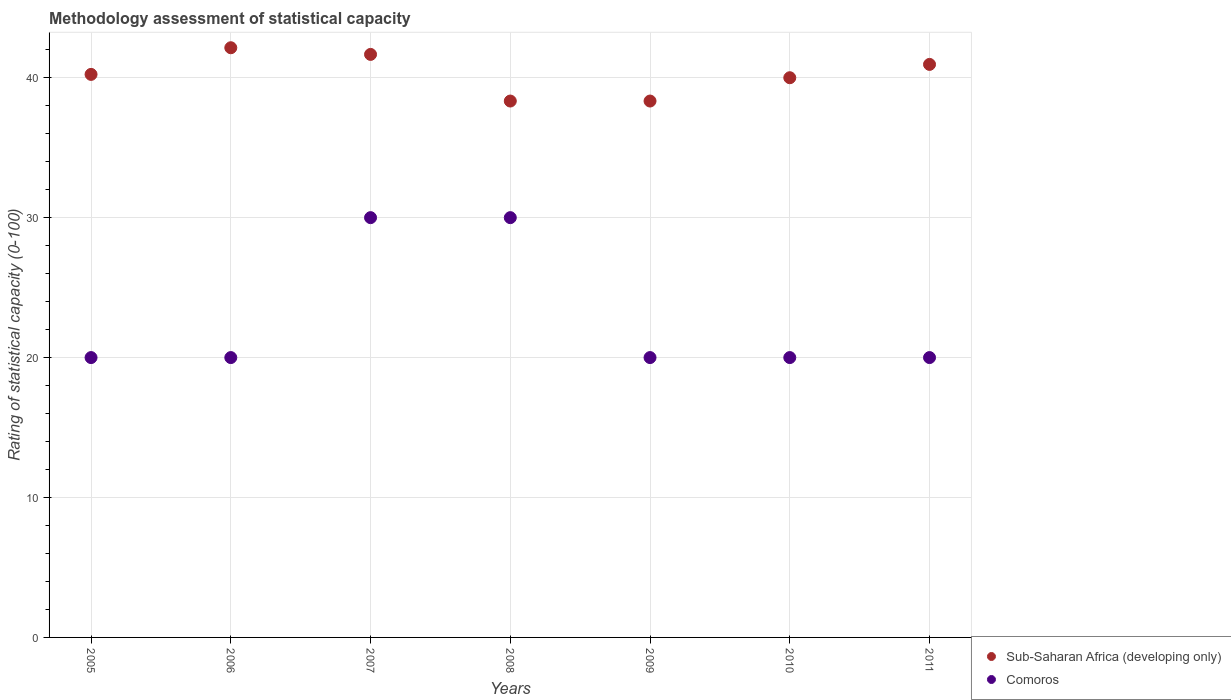How many different coloured dotlines are there?
Keep it short and to the point. 2. Is the number of dotlines equal to the number of legend labels?
Provide a short and direct response. Yes. Across all years, what is the maximum rating of statistical capacity in Sub-Saharan Africa (developing only)?
Provide a succinct answer. 42.14. In which year was the rating of statistical capacity in Comoros minimum?
Provide a succinct answer. 2005. What is the total rating of statistical capacity in Comoros in the graph?
Provide a short and direct response. 160. What is the difference between the rating of statistical capacity in Sub-Saharan Africa (developing only) in 2006 and that in 2008?
Make the answer very short. 3.81. What is the difference between the rating of statistical capacity in Sub-Saharan Africa (developing only) in 2010 and the rating of statistical capacity in Comoros in 2007?
Provide a succinct answer. 10. What is the average rating of statistical capacity in Comoros per year?
Provide a short and direct response. 22.86. In the year 2009, what is the difference between the rating of statistical capacity in Sub-Saharan Africa (developing only) and rating of statistical capacity in Comoros?
Your response must be concise. 18.33. What is the difference between the highest and the second highest rating of statistical capacity in Sub-Saharan Africa (developing only)?
Offer a very short reply. 0.48. What is the difference between the highest and the lowest rating of statistical capacity in Sub-Saharan Africa (developing only)?
Keep it short and to the point. 3.81. In how many years, is the rating of statistical capacity in Sub-Saharan Africa (developing only) greater than the average rating of statistical capacity in Sub-Saharan Africa (developing only) taken over all years?
Offer a terse response. 3. Is the sum of the rating of statistical capacity in Comoros in 2006 and 2008 greater than the maximum rating of statistical capacity in Sub-Saharan Africa (developing only) across all years?
Make the answer very short. Yes. Is the rating of statistical capacity in Sub-Saharan Africa (developing only) strictly greater than the rating of statistical capacity in Comoros over the years?
Your answer should be compact. Yes. How many years are there in the graph?
Offer a terse response. 7. What is the title of the graph?
Your answer should be compact. Methodology assessment of statistical capacity. What is the label or title of the Y-axis?
Offer a very short reply. Rating of statistical capacity (0-100). What is the Rating of statistical capacity (0-100) of Sub-Saharan Africa (developing only) in 2005?
Keep it short and to the point. 40.24. What is the Rating of statistical capacity (0-100) in Comoros in 2005?
Your answer should be very brief. 20. What is the Rating of statistical capacity (0-100) in Sub-Saharan Africa (developing only) in 2006?
Keep it short and to the point. 42.14. What is the Rating of statistical capacity (0-100) of Sub-Saharan Africa (developing only) in 2007?
Provide a succinct answer. 41.67. What is the Rating of statistical capacity (0-100) of Sub-Saharan Africa (developing only) in 2008?
Your response must be concise. 38.33. What is the Rating of statistical capacity (0-100) in Sub-Saharan Africa (developing only) in 2009?
Ensure brevity in your answer.  38.33. What is the Rating of statistical capacity (0-100) in Comoros in 2009?
Offer a terse response. 20. What is the Rating of statistical capacity (0-100) in Sub-Saharan Africa (developing only) in 2010?
Your response must be concise. 40. What is the Rating of statistical capacity (0-100) of Sub-Saharan Africa (developing only) in 2011?
Your answer should be compact. 40.95. What is the Rating of statistical capacity (0-100) in Comoros in 2011?
Your answer should be compact. 20. Across all years, what is the maximum Rating of statistical capacity (0-100) of Sub-Saharan Africa (developing only)?
Offer a very short reply. 42.14. Across all years, what is the maximum Rating of statistical capacity (0-100) in Comoros?
Your answer should be very brief. 30. Across all years, what is the minimum Rating of statistical capacity (0-100) in Sub-Saharan Africa (developing only)?
Ensure brevity in your answer.  38.33. What is the total Rating of statistical capacity (0-100) in Sub-Saharan Africa (developing only) in the graph?
Make the answer very short. 281.67. What is the total Rating of statistical capacity (0-100) of Comoros in the graph?
Offer a terse response. 160. What is the difference between the Rating of statistical capacity (0-100) of Sub-Saharan Africa (developing only) in 2005 and that in 2006?
Your answer should be compact. -1.9. What is the difference between the Rating of statistical capacity (0-100) in Sub-Saharan Africa (developing only) in 2005 and that in 2007?
Your response must be concise. -1.43. What is the difference between the Rating of statistical capacity (0-100) in Comoros in 2005 and that in 2007?
Make the answer very short. -10. What is the difference between the Rating of statistical capacity (0-100) of Sub-Saharan Africa (developing only) in 2005 and that in 2008?
Your answer should be compact. 1.9. What is the difference between the Rating of statistical capacity (0-100) in Comoros in 2005 and that in 2008?
Provide a succinct answer. -10. What is the difference between the Rating of statistical capacity (0-100) of Sub-Saharan Africa (developing only) in 2005 and that in 2009?
Ensure brevity in your answer.  1.9. What is the difference between the Rating of statistical capacity (0-100) of Sub-Saharan Africa (developing only) in 2005 and that in 2010?
Your answer should be very brief. 0.24. What is the difference between the Rating of statistical capacity (0-100) of Comoros in 2005 and that in 2010?
Your answer should be compact. 0. What is the difference between the Rating of statistical capacity (0-100) in Sub-Saharan Africa (developing only) in 2005 and that in 2011?
Offer a terse response. -0.71. What is the difference between the Rating of statistical capacity (0-100) of Sub-Saharan Africa (developing only) in 2006 and that in 2007?
Ensure brevity in your answer.  0.48. What is the difference between the Rating of statistical capacity (0-100) in Sub-Saharan Africa (developing only) in 2006 and that in 2008?
Offer a terse response. 3.81. What is the difference between the Rating of statistical capacity (0-100) of Sub-Saharan Africa (developing only) in 2006 and that in 2009?
Provide a short and direct response. 3.81. What is the difference between the Rating of statistical capacity (0-100) of Sub-Saharan Africa (developing only) in 2006 and that in 2010?
Ensure brevity in your answer.  2.14. What is the difference between the Rating of statistical capacity (0-100) in Comoros in 2006 and that in 2010?
Your answer should be compact. 0. What is the difference between the Rating of statistical capacity (0-100) in Sub-Saharan Africa (developing only) in 2006 and that in 2011?
Your response must be concise. 1.19. What is the difference between the Rating of statistical capacity (0-100) in Sub-Saharan Africa (developing only) in 2007 and that in 2008?
Offer a very short reply. 3.33. What is the difference between the Rating of statistical capacity (0-100) in Comoros in 2007 and that in 2008?
Keep it short and to the point. 0. What is the difference between the Rating of statistical capacity (0-100) in Comoros in 2007 and that in 2009?
Ensure brevity in your answer.  10. What is the difference between the Rating of statistical capacity (0-100) of Sub-Saharan Africa (developing only) in 2007 and that in 2010?
Provide a succinct answer. 1.67. What is the difference between the Rating of statistical capacity (0-100) in Comoros in 2007 and that in 2010?
Ensure brevity in your answer.  10. What is the difference between the Rating of statistical capacity (0-100) of Sub-Saharan Africa (developing only) in 2007 and that in 2011?
Your answer should be compact. 0.71. What is the difference between the Rating of statistical capacity (0-100) in Sub-Saharan Africa (developing only) in 2008 and that in 2009?
Provide a succinct answer. 0. What is the difference between the Rating of statistical capacity (0-100) in Sub-Saharan Africa (developing only) in 2008 and that in 2010?
Offer a very short reply. -1.67. What is the difference between the Rating of statistical capacity (0-100) in Comoros in 2008 and that in 2010?
Provide a short and direct response. 10. What is the difference between the Rating of statistical capacity (0-100) in Sub-Saharan Africa (developing only) in 2008 and that in 2011?
Provide a succinct answer. -2.62. What is the difference between the Rating of statistical capacity (0-100) of Sub-Saharan Africa (developing only) in 2009 and that in 2010?
Make the answer very short. -1.67. What is the difference between the Rating of statistical capacity (0-100) of Comoros in 2009 and that in 2010?
Provide a succinct answer. 0. What is the difference between the Rating of statistical capacity (0-100) of Sub-Saharan Africa (developing only) in 2009 and that in 2011?
Keep it short and to the point. -2.62. What is the difference between the Rating of statistical capacity (0-100) in Sub-Saharan Africa (developing only) in 2010 and that in 2011?
Ensure brevity in your answer.  -0.95. What is the difference between the Rating of statistical capacity (0-100) in Sub-Saharan Africa (developing only) in 2005 and the Rating of statistical capacity (0-100) in Comoros in 2006?
Ensure brevity in your answer.  20.24. What is the difference between the Rating of statistical capacity (0-100) in Sub-Saharan Africa (developing only) in 2005 and the Rating of statistical capacity (0-100) in Comoros in 2007?
Your response must be concise. 10.24. What is the difference between the Rating of statistical capacity (0-100) of Sub-Saharan Africa (developing only) in 2005 and the Rating of statistical capacity (0-100) of Comoros in 2008?
Offer a very short reply. 10.24. What is the difference between the Rating of statistical capacity (0-100) of Sub-Saharan Africa (developing only) in 2005 and the Rating of statistical capacity (0-100) of Comoros in 2009?
Ensure brevity in your answer.  20.24. What is the difference between the Rating of statistical capacity (0-100) in Sub-Saharan Africa (developing only) in 2005 and the Rating of statistical capacity (0-100) in Comoros in 2010?
Ensure brevity in your answer.  20.24. What is the difference between the Rating of statistical capacity (0-100) in Sub-Saharan Africa (developing only) in 2005 and the Rating of statistical capacity (0-100) in Comoros in 2011?
Give a very brief answer. 20.24. What is the difference between the Rating of statistical capacity (0-100) of Sub-Saharan Africa (developing only) in 2006 and the Rating of statistical capacity (0-100) of Comoros in 2007?
Your answer should be compact. 12.14. What is the difference between the Rating of statistical capacity (0-100) in Sub-Saharan Africa (developing only) in 2006 and the Rating of statistical capacity (0-100) in Comoros in 2008?
Keep it short and to the point. 12.14. What is the difference between the Rating of statistical capacity (0-100) of Sub-Saharan Africa (developing only) in 2006 and the Rating of statistical capacity (0-100) of Comoros in 2009?
Keep it short and to the point. 22.14. What is the difference between the Rating of statistical capacity (0-100) in Sub-Saharan Africa (developing only) in 2006 and the Rating of statistical capacity (0-100) in Comoros in 2010?
Your answer should be very brief. 22.14. What is the difference between the Rating of statistical capacity (0-100) in Sub-Saharan Africa (developing only) in 2006 and the Rating of statistical capacity (0-100) in Comoros in 2011?
Provide a short and direct response. 22.14. What is the difference between the Rating of statistical capacity (0-100) of Sub-Saharan Africa (developing only) in 2007 and the Rating of statistical capacity (0-100) of Comoros in 2008?
Your answer should be very brief. 11.67. What is the difference between the Rating of statistical capacity (0-100) of Sub-Saharan Africa (developing only) in 2007 and the Rating of statistical capacity (0-100) of Comoros in 2009?
Make the answer very short. 21.67. What is the difference between the Rating of statistical capacity (0-100) in Sub-Saharan Africa (developing only) in 2007 and the Rating of statistical capacity (0-100) in Comoros in 2010?
Your response must be concise. 21.67. What is the difference between the Rating of statistical capacity (0-100) of Sub-Saharan Africa (developing only) in 2007 and the Rating of statistical capacity (0-100) of Comoros in 2011?
Your response must be concise. 21.67. What is the difference between the Rating of statistical capacity (0-100) of Sub-Saharan Africa (developing only) in 2008 and the Rating of statistical capacity (0-100) of Comoros in 2009?
Keep it short and to the point. 18.33. What is the difference between the Rating of statistical capacity (0-100) in Sub-Saharan Africa (developing only) in 2008 and the Rating of statistical capacity (0-100) in Comoros in 2010?
Ensure brevity in your answer.  18.33. What is the difference between the Rating of statistical capacity (0-100) in Sub-Saharan Africa (developing only) in 2008 and the Rating of statistical capacity (0-100) in Comoros in 2011?
Ensure brevity in your answer.  18.33. What is the difference between the Rating of statistical capacity (0-100) in Sub-Saharan Africa (developing only) in 2009 and the Rating of statistical capacity (0-100) in Comoros in 2010?
Your answer should be compact. 18.33. What is the difference between the Rating of statistical capacity (0-100) of Sub-Saharan Africa (developing only) in 2009 and the Rating of statistical capacity (0-100) of Comoros in 2011?
Offer a terse response. 18.33. What is the average Rating of statistical capacity (0-100) of Sub-Saharan Africa (developing only) per year?
Offer a very short reply. 40.24. What is the average Rating of statistical capacity (0-100) of Comoros per year?
Give a very brief answer. 22.86. In the year 2005, what is the difference between the Rating of statistical capacity (0-100) of Sub-Saharan Africa (developing only) and Rating of statistical capacity (0-100) of Comoros?
Make the answer very short. 20.24. In the year 2006, what is the difference between the Rating of statistical capacity (0-100) of Sub-Saharan Africa (developing only) and Rating of statistical capacity (0-100) of Comoros?
Offer a very short reply. 22.14. In the year 2007, what is the difference between the Rating of statistical capacity (0-100) in Sub-Saharan Africa (developing only) and Rating of statistical capacity (0-100) in Comoros?
Provide a succinct answer. 11.67. In the year 2008, what is the difference between the Rating of statistical capacity (0-100) in Sub-Saharan Africa (developing only) and Rating of statistical capacity (0-100) in Comoros?
Your answer should be compact. 8.33. In the year 2009, what is the difference between the Rating of statistical capacity (0-100) in Sub-Saharan Africa (developing only) and Rating of statistical capacity (0-100) in Comoros?
Your answer should be very brief. 18.33. In the year 2011, what is the difference between the Rating of statistical capacity (0-100) in Sub-Saharan Africa (developing only) and Rating of statistical capacity (0-100) in Comoros?
Make the answer very short. 20.95. What is the ratio of the Rating of statistical capacity (0-100) of Sub-Saharan Africa (developing only) in 2005 to that in 2006?
Your answer should be very brief. 0.95. What is the ratio of the Rating of statistical capacity (0-100) of Sub-Saharan Africa (developing only) in 2005 to that in 2007?
Provide a short and direct response. 0.97. What is the ratio of the Rating of statistical capacity (0-100) in Comoros in 2005 to that in 2007?
Offer a terse response. 0.67. What is the ratio of the Rating of statistical capacity (0-100) in Sub-Saharan Africa (developing only) in 2005 to that in 2008?
Ensure brevity in your answer.  1.05. What is the ratio of the Rating of statistical capacity (0-100) of Sub-Saharan Africa (developing only) in 2005 to that in 2009?
Offer a very short reply. 1.05. What is the ratio of the Rating of statistical capacity (0-100) in Sub-Saharan Africa (developing only) in 2005 to that in 2011?
Give a very brief answer. 0.98. What is the ratio of the Rating of statistical capacity (0-100) in Sub-Saharan Africa (developing only) in 2006 to that in 2007?
Keep it short and to the point. 1.01. What is the ratio of the Rating of statistical capacity (0-100) in Sub-Saharan Africa (developing only) in 2006 to that in 2008?
Provide a short and direct response. 1.1. What is the ratio of the Rating of statistical capacity (0-100) of Comoros in 2006 to that in 2008?
Your answer should be compact. 0.67. What is the ratio of the Rating of statistical capacity (0-100) of Sub-Saharan Africa (developing only) in 2006 to that in 2009?
Make the answer very short. 1.1. What is the ratio of the Rating of statistical capacity (0-100) in Comoros in 2006 to that in 2009?
Provide a succinct answer. 1. What is the ratio of the Rating of statistical capacity (0-100) of Sub-Saharan Africa (developing only) in 2006 to that in 2010?
Offer a very short reply. 1.05. What is the ratio of the Rating of statistical capacity (0-100) in Sub-Saharan Africa (developing only) in 2006 to that in 2011?
Keep it short and to the point. 1.03. What is the ratio of the Rating of statistical capacity (0-100) in Sub-Saharan Africa (developing only) in 2007 to that in 2008?
Ensure brevity in your answer.  1.09. What is the ratio of the Rating of statistical capacity (0-100) in Sub-Saharan Africa (developing only) in 2007 to that in 2009?
Keep it short and to the point. 1.09. What is the ratio of the Rating of statistical capacity (0-100) of Sub-Saharan Africa (developing only) in 2007 to that in 2010?
Your answer should be very brief. 1.04. What is the ratio of the Rating of statistical capacity (0-100) of Comoros in 2007 to that in 2010?
Keep it short and to the point. 1.5. What is the ratio of the Rating of statistical capacity (0-100) in Sub-Saharan Africa (developing only) in 2007 to that in 2011?
Your answer should be compact. 1.02. What is the ratio of the Rating of statistical capacity (0-100) in Comoros in 2007 to that in 2011?
Give a very brief answer. 1.5. What is the ratio of the Rating of statistical capacity (0-100) in Comoros in 2008 to that in 2009?
Offer a terse response. 1.5. What is the ratio of the Rating of statistical capacity (0-100) in Comoros in 2008 to that in 2010?
Provide a short and direct response. 1.5. What is the ratio of the Rating of statistical capacity (0-100) of Sub-Saharan Africa (developing only) in 2008 to that in 2011?
Offer a very short reply. 0.94. What is the ratio of the Rating of statistical capacity (0-100) of Sub-Saharan Africa (developing only) in 2009 to that in 2010?
Your answer should be very brief. 0.96. What is the ratio of the Rating of statistical capacity (0-100) of Comoros in 2009 to that in 2010?
Offer a very short reply. 1. What is the ratio of the Rating of statistical capacity (0-100) in Sub-Saharan Africa (developing only) in 2009 to that in 2011?
Keep it short and to the point. 0.94. What is the ratio of the Rating of statistical capacity (0-100) in Sub-Saharan Africa (developing only) in 2010 to that in 2011?
Ensure brevity in your answer.  0.98. What is the ratio of the Rating of statistical capacity (0-100) of Comoros in 2010 to that in 2011?
Ensure brevity in your answer.  1. What is the difference between the highest and the second highest Rating of statistical capacity (0-100) of Sub-Saharan Africa (developing only)?
Make the answer very short. 0.48. What is the difference between the highest and the second highest Rating of statistical capacity (0-100) of Comoros?
Offer a terse response. 0. What is the difference between the highest and the lowest Rating of statistical capacity (0-100) in Sub-Saharan Africa (developing only)?
Your response must be concise. 3.81. What is the difference between the highest and the lowest Rating of statistical capacity (0-100) in Comoros?
Make the answer very short. 10. 